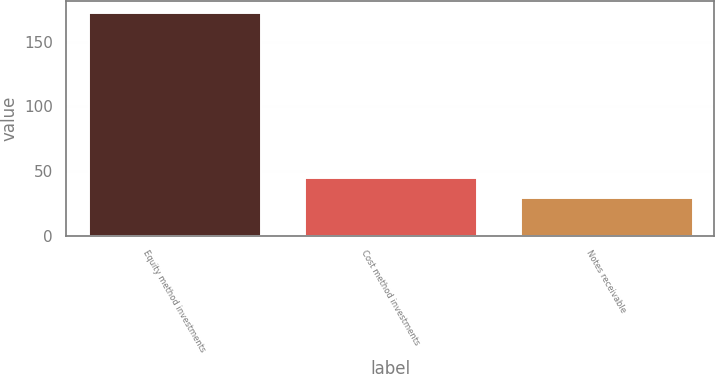Convert chart. <chart><loc_0><loc_0><loc_500><loc_500><bar_chart><fcel>Equity method investments<fcel>Cost method investments<fcel>Notes receivable<nl><fcel>173<fcel>45<fcel>30<nl></chart> 